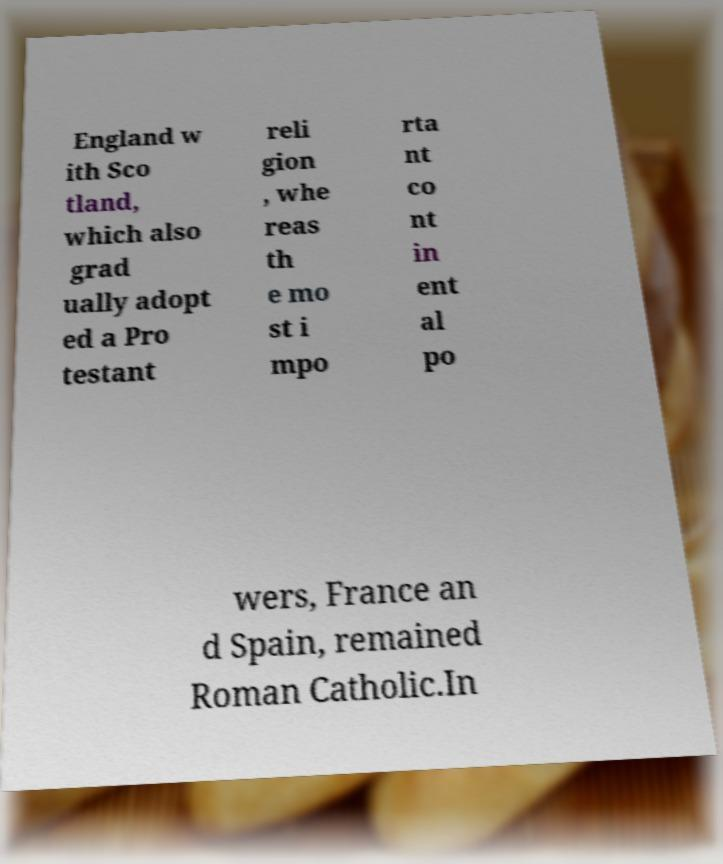There's text embedded in this image that I need extracted. Can you transcribe it verbatim? England w ith Sco tland, which also grad ually adopt ed a Pro testant reli gion , whe reas th e mo st i mpo rta nt co nt in ent al po wers, France an d Spain, remained Roman Catholic.In 